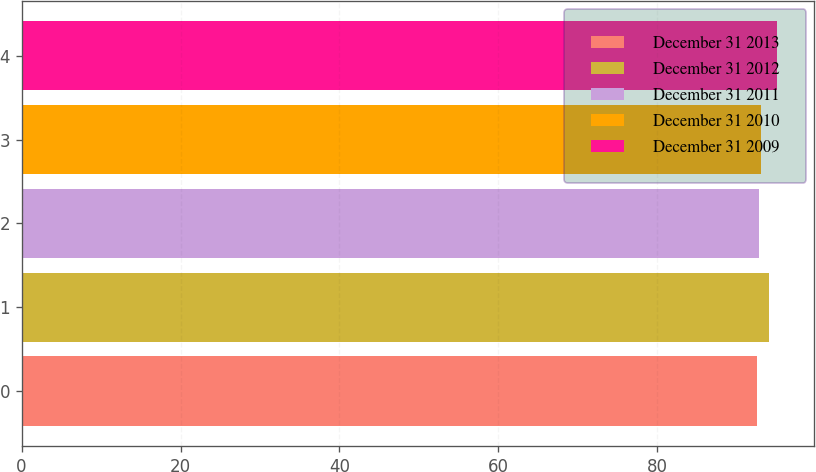Convert chart. <chart><loc_0><loc_0><loc_500><loc_500><bar_chart><fcel>December 31 2013<fcel>December 31 2012<fcel>December 31 2011<fcel>December 31 2010<fcel>December 31 2009<nl><fcel>92.5<fcel>94.1<fcel>92.75<fcel>93<fcel>95<nl></chart> 